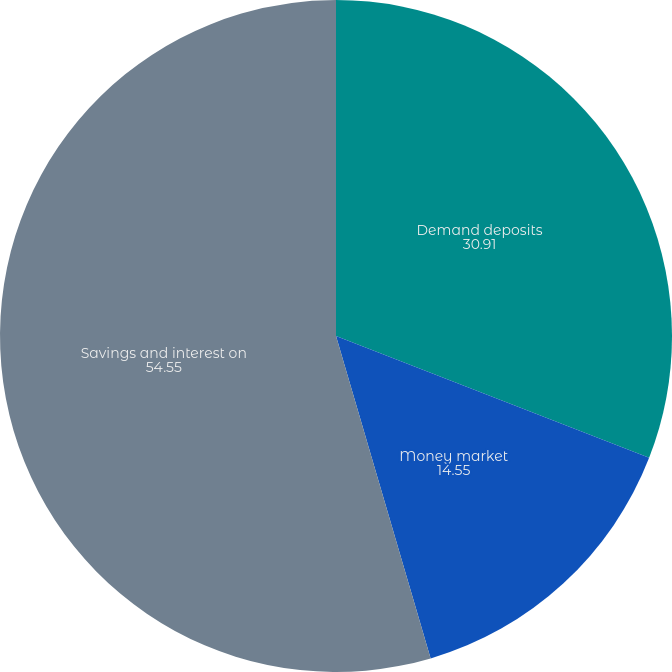<chart> <loc_0><loc_0><loc_500><loc_500><pie_chart><fcel>Demand deposits<fcel>Money market<fcel>Savings and interest on<nl><fcel>30.91%<fcel>14.55%<fcel>54.55%<nl></chart> 